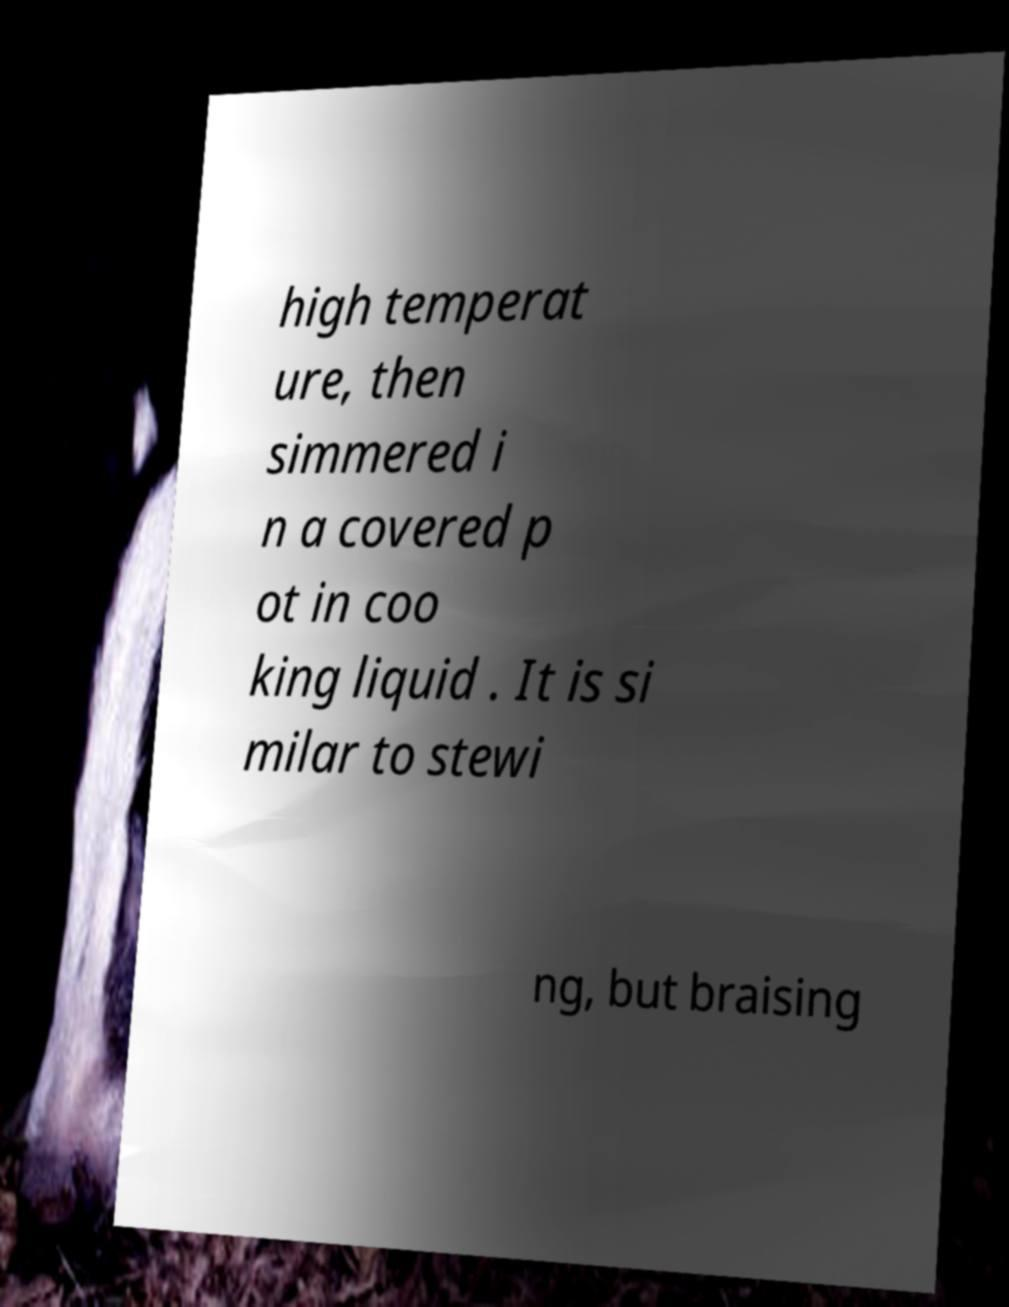Could you assist in decoding the text presented in this image and type it out clearly? high temperat ure, then simmered i n a covered p ot in coo king liquid . It is si milar to stewi ng, but braising 